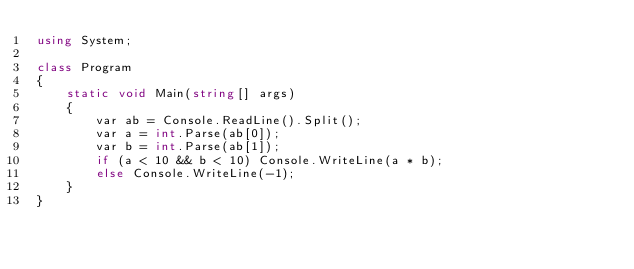Convert code to text. <code><loc_0><loc_0><loc_500><loc_500><_C#_>using System;

class Program
{
    static void Main(string[] args)
    {
        var ab = Console.ReadLine().Split();
        var a = int.Parse(ab[0]);
        var b = int.Parse(ab[1]);
        if (a < 10 && b < 10) Console.WriteLine(a * b);
        else Console.WriteLine(-1);
    }
}
</code> 